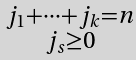<formula> <loc_0><loc_0><loc_500><loc_500>\begin{smallmatrix} j _ { 1 } + \dots + j _ { k } = n \\ j _ { s } \geq 0 \end{smallmatrix}</formula> 